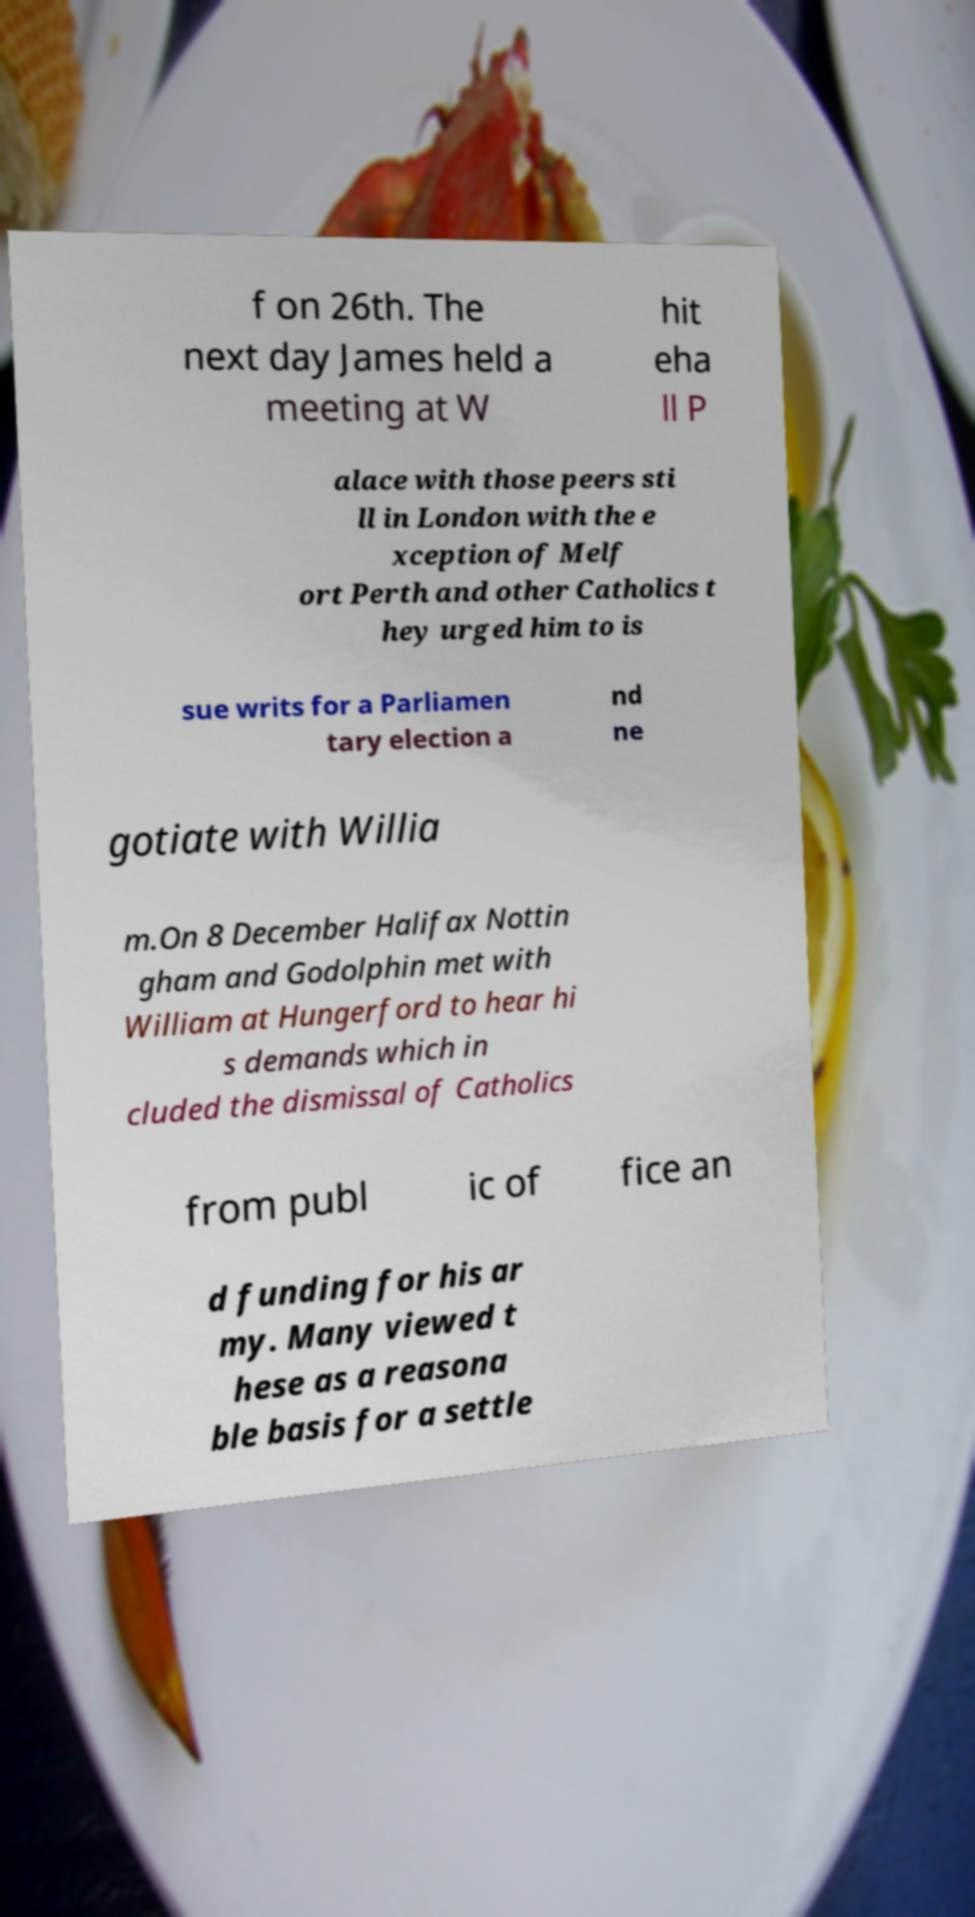Could you assist in decoding the text presented in this image and type it out clearly? f on 26th. The next day James held a meeting at W hit eha ll P alace with those peers sti ll in London with the e xception of Melf ort Perth and other Catholics t hey urged him to is sue writs for a Parliamen tary election a nd ne gotiate with Willia m.On 8 December Halifax Nottin gham and Godolphin met with William at Hungerford to hear hi s demands which in cluded the dismissal of Catholics from publ ic of fice an d funding for his ar my. Many viewed t hese as a reasona ble basis for a settle 